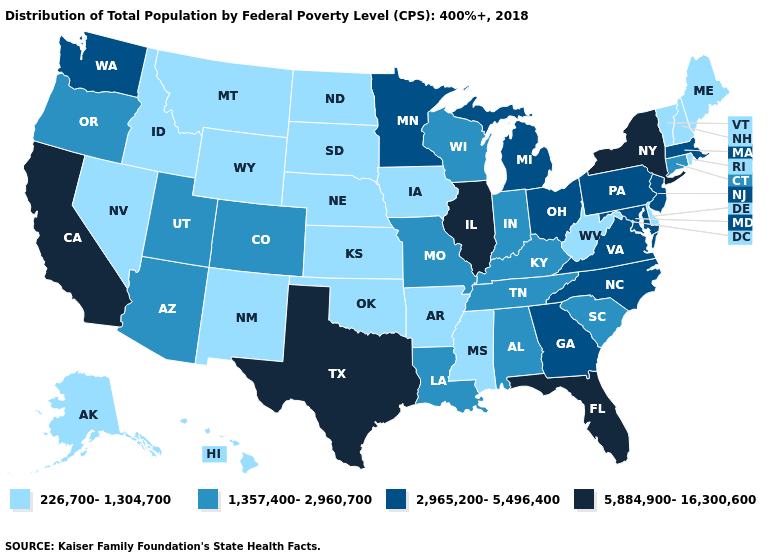What is the value of North Carolina?
Give a very brief answer. 2,965,200-5,496,400. Which states hav the highest value in the West?
Be succinct. California. Does Nevada have the lowest value in the USA?
Write a very short answer. Yes. What is the value of New York?
Write a very short answer. 5,884,900-16,300,600. Which states have the lowest value in the USA?
Keep it brief. Alaska, Arkansas, Delaware, Hawaii, Idaho, Iowa, Kansas, Maine, Mississippi, Montana, Nebraska, Nevada, New Hampshire, New Mexico, North Dakota, Oklahoma, Rhode Island, South Dakota, Vermont, West Virginia, Wyoming. Name the states that have a value in the range 226,700-1,304,700?
Short answer required. Alaska, Arkansas, Delaware, Hawaii, Idaho, Iowa, Kansas, Maine, Mississippi, Montana, Nebraska, Nevada, New Hampshire, New Mexico, North Dakota, Oklahoma, Rhode Island, South Dakota, Vermont, West Virginia, Wyoming. Does Vermont have a higher value than Texas?
Short answer required. No. Name the states that have a value in the range 1,357,400-2,960,700?
Be succinct. Alabama, Arizona, Colorado, Connecticut, Indiana, Kentucky, Louisiana, Missouri, Oregon, South Carolina, Tennessee, Utah, Wisconsin. Name the states that have a value in the range 5,884,900-16,300,600?
Answer briefly. California, Florida, Illinois, New York, Texas. Which states have the highest value in the USA?
Write a very short answer. California, Florida, Illinois, New York, Texas. Does the first symbol in the legend represent the smallest category?
Give a very brief answer. Yes. Does Utah have a higher value than Wyoming?
Short answer required. Yes. What is the highest value in the USA?
Keep it brief. 5,884,900-16,300,600. Does South Dakota have the highest value in the USA?
Short answer required. No. Name the states that have a value in the range 1,357,400-2,960,700?
Keep it brief. Alabama, Arizona, Colorado, Connecticut, Indiana, Kentucky, Louisiana, Missouri, Oregon, South Carolina, Tennessee, Utah, Wisconsin. 